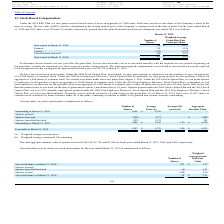From Avx Corporation's financial document, What is the number of nonvested shares at March 31, 2018 and 2019 respectively? The document shows two values: 358 and 433. From the document: "Non-vested at March 31, 2018 358 $ 16.27 Non-vested at March 31, 2019 433 $ 15.55..." Also, What is the number of options granted and vested respectively? The document shows two values: 315 and (172). From the document: "Granted 315 15.28 Vested (172) 16.27..." Also, What is the weighted average grant date fair value per share at March 31, 2018 and 2019 respectively? The document shows two values: $16.27 and $15.55. From the document: "Non-vested at March 31, 2019 433 $ 15.55 Non-vested at March 31, 2018 358 $ 16.27..." Also, can you calculate: What is the percentage change in the weighted average grant date fair value per share between 2018 and 2019? To answer this question, I need to perform calculations using the financial data. The calculation is: (15.55-16.27)/16.27 , which equals -4.43 (percentage). This is based on the information: "Non-vested at March 31, 2018 358 $ 16.27 Non-vested at March 31, 2019 433 $ 15.55..." The key data points involved are: 15.55, 16.27. Also, can you calculate: What is the total unrecognised compensation costs related to unvested stock awards as a percentage of the value of nonvested shares at March 31, 2019?  To answer this question, I need to perform calculations using the financial data. The calculation is: 1,476/ (433 * 15.55) , which equals 21.92 (percentage). This is based on the information: "Non-vested at March 31, 2019 433 $ 15.55 Non-vested at March 31, 2019 433 $ 15.55 e vesting period, approximately three years, was $1,476 at March 31, 2019...." The key data points involved are: 1,476, 15.55, 433. Also, can you calculate: What is the percentage change in the number of nonvested shares between March 31, 2018 and 2019?  To answer this question, I need to perform calculations using the financial data. The calculation is: (433 - 358)/358 , which equals 20.95 (percentage). This is based on the information: "Non-vested at March 31, 2018 358 $ 16.27 Non-vested at March 31, 2019 433 $ 15.55..." The key data points involved are: 358, 433. 